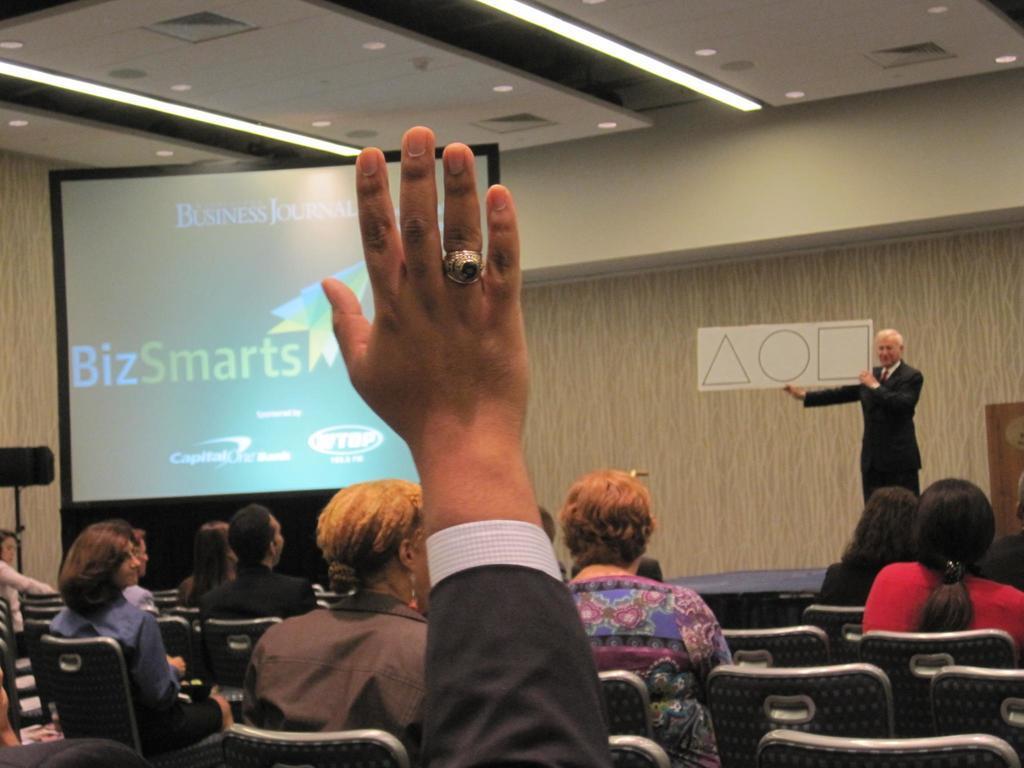In one or two sentences, can you explain what this image depicts? In this picture I can see some of the students sitting on the chair. I can see a person standing on the right side. I can see the hand of a person. I can see the screen on the left side. I can see light arrangements on the roof. 